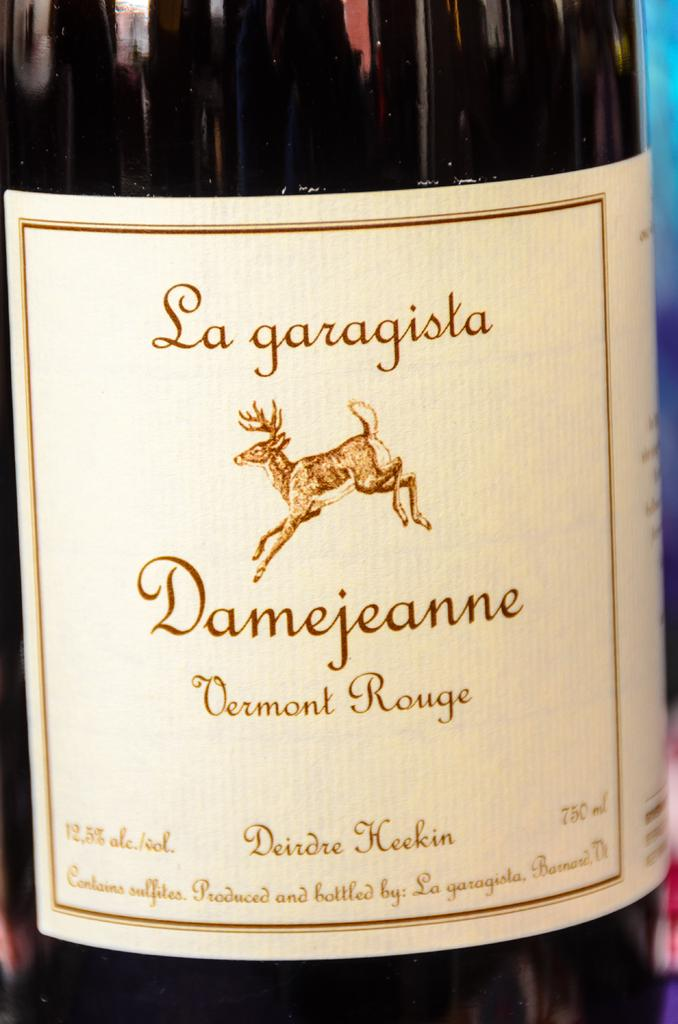What object is present in the image? There is a bottle in the image. What can be found on the bottle? There is text and an animal image on the bottle. What type of apparel is the animal wearing in the image? There is no apparel or animal wearing apparel present in the image; it only features a bottle with text and an animal image. 